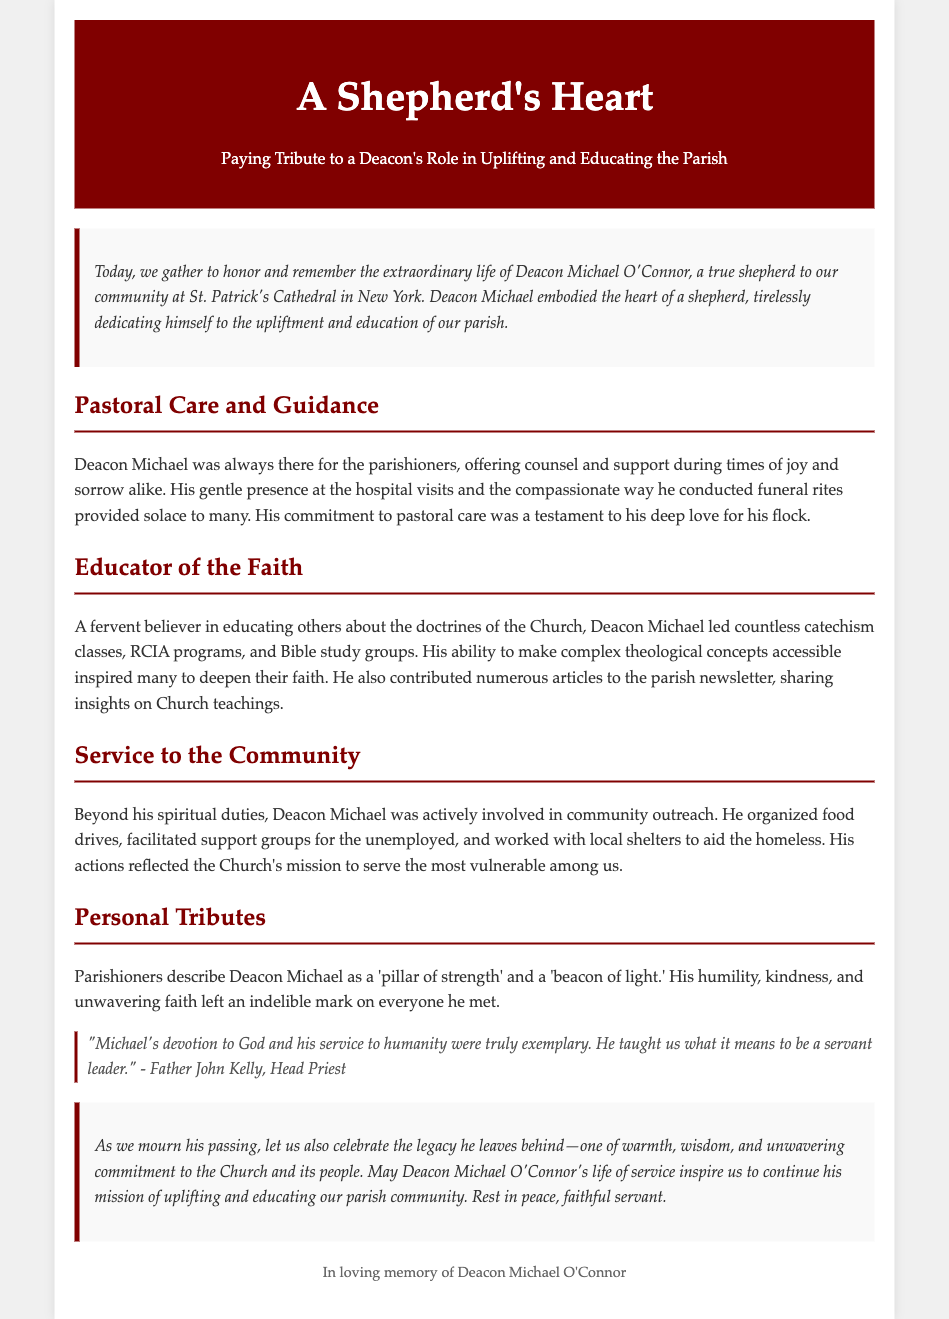What is the title of the eulogy? The title is prominently stated at the top of the document to set the theme for the tribute, which is “A Shepherd's Heart.”
Answer: A Shepherd's Heart Who is the eulogy for? The document identifies the person being honored as Deacon Michael O'Connor in the introductory paragraph.
Answer: Deacon Michael O'Connor What was Deacon Michael's role at St. Patrick's Cathedral? The eulogy describes him as a "shepherd" to the community, indicating his pastoral role in the church.
Answer: Shepherd What did Deacon Michael offer to the parishioners during times of sorrow? The document details his compassionate actions during difficult times, particularly in funeral rites, providing comfort to families.
Answer: Solace How did Deacon Michael contribute to the education of the faith? The eulogy lists his involvement in teaching catechism, leading RCIA programs, and Bible studies, showcasing his educational efforts.
Answer: Catechism classes What qualities did parishioners attribute to Deacon Michael? The eulogy features personal tributes, highlighting how he was viewed as a 'pillar of strength' and a 'beacon of light.'
Answer: Pillar of strength What community service activities did Deacon Michael participate in? The document mentions several activities he led, such as food drives and support groups, underlining his community involvement.
Answer: Food drives Who described Deacon Michael's devotion as exemplary? A quote in the personal tributes section attributes this description to Father John Kelly, indicating his respect for Deacon Michael's commitment.
Answer: Father John Kelly What legacy does the eulogy suggest Deacon Michael leaves behind? The conclusion emphasizes that the legacy consists of warmth, wisdom, and a commitment to uplifting the parish community.
Answer: Warmth, wisdom, commitment 